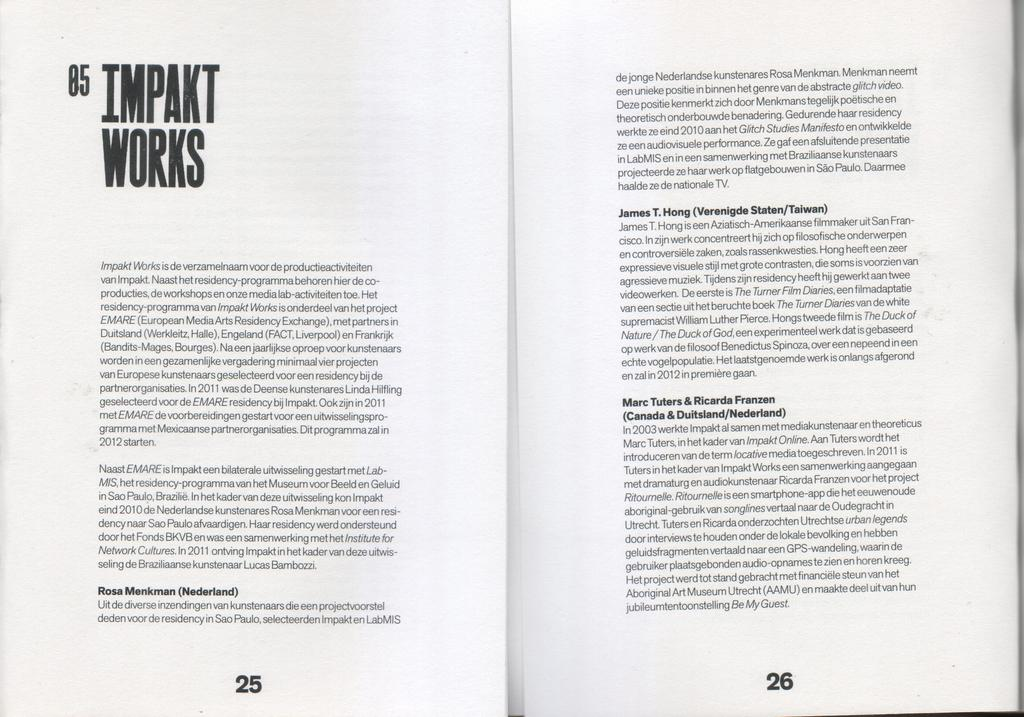<image>
Relay a brief, clear account of the picture shown. A book is open to page 25 and 26 with the title Impakt Works. 